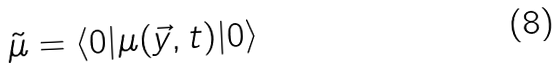Convert formula to latex. <formula><loc_0><loc_0><loc_500><loc_500>\tilde { \mu } = \langle 0 | \mu ( \vec { y } , t ) | 0 \rangle</formula> 